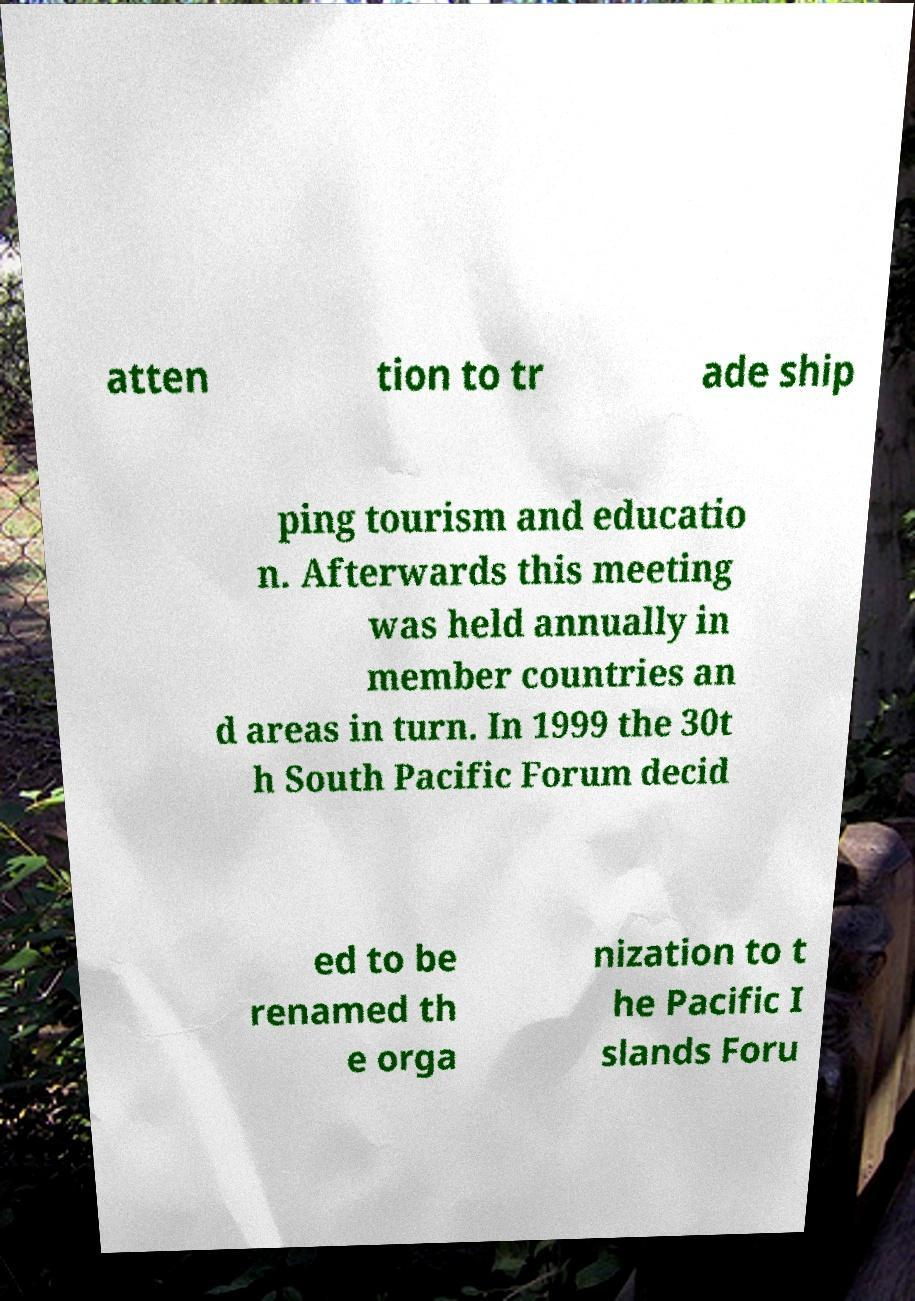Could you extract and type out the text from this image? atten tion to tr ade ship ping tourism and educatio n. Afterwards this meeting was held annually in member countries an d areas in turn. In 1999 the 30t h South Pacific Forum decid ed to be renamed th e orga nization to t he Pacific I slands Foru 